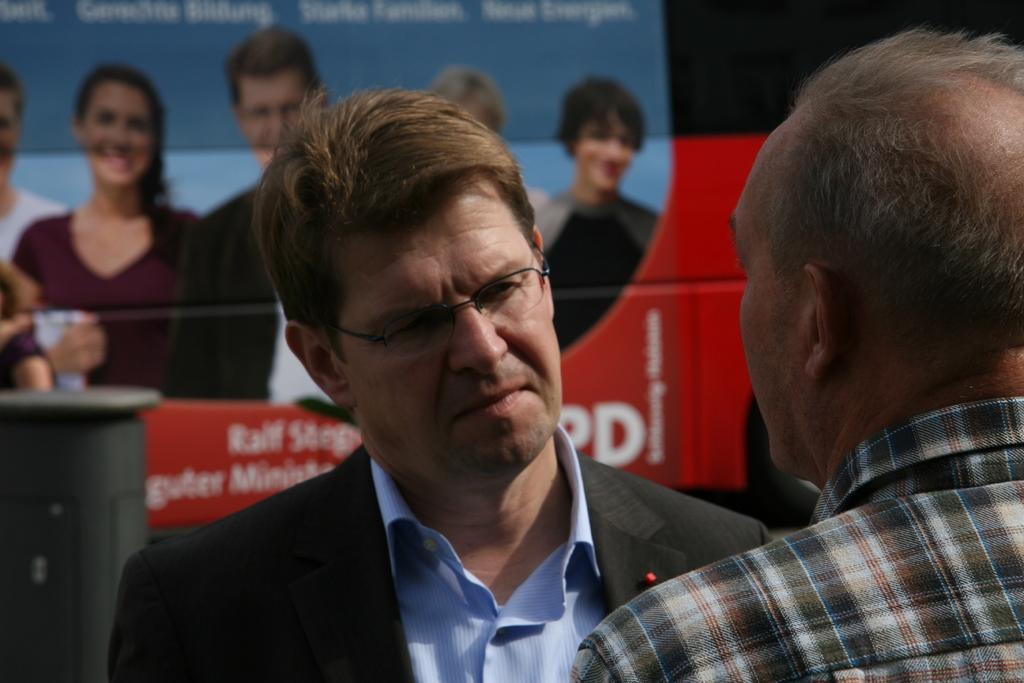Please provide a concise description of this image. In this picture we can see there are two people standing and behind the people there is a banner. 